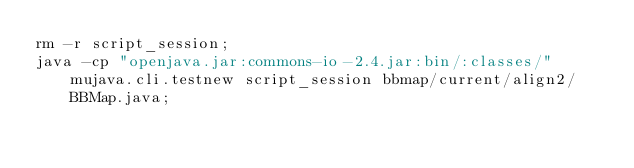<code> <loc_0><loc_0><loc_500><loc_500><_Bash_>rm -r script_session;
java -cp "openjava.jar:commons-io-2.4.jar:bin/:classes/" mujava.cli.testnew script_session bbmap/current/align2/BBMap.java;
</code> 